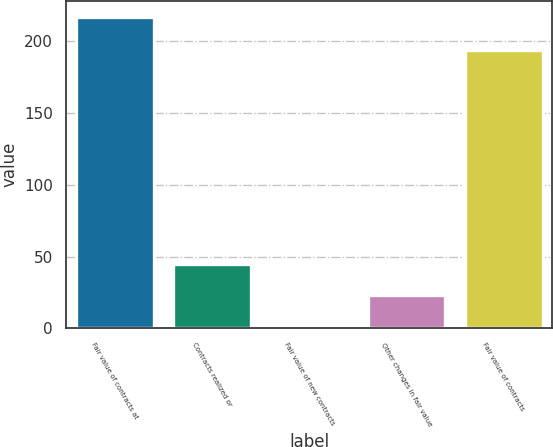Convert chart to OTSL. <chart><loc_0><loc_0><loc_500><loc_500><bar_chart><fcel>Fair value of contracts at<fcel>Contracts realized or<fcel>Fair value of new contracts<fcel>Other changes in fair value<fcel>Fair value of contracts<nl><fcel>217<fcel>45<fcel>2<fcel>23.5<fcel>194<nl></chart> 